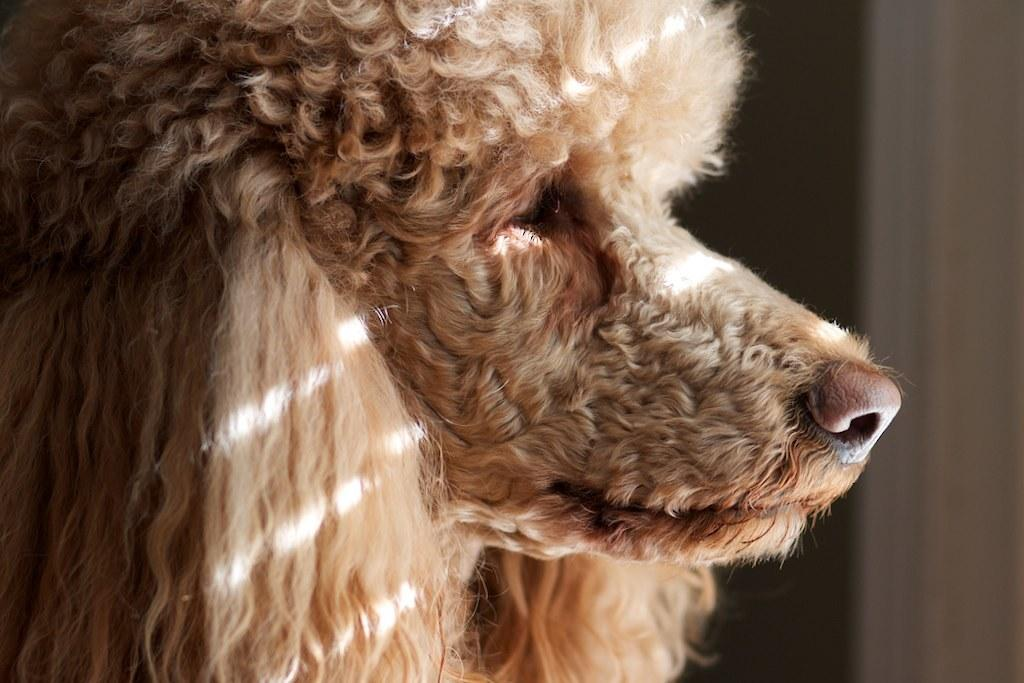What type of animal is present in the image? There is a dog in the image. What type of knot is the dog using to tie its leash in the image? There is no leash or knot present in the image; it only features a dog. What type of eggnog is the dog drinking in the image? There is no eggnog or drinking activity present in the image; it only features a dog. 